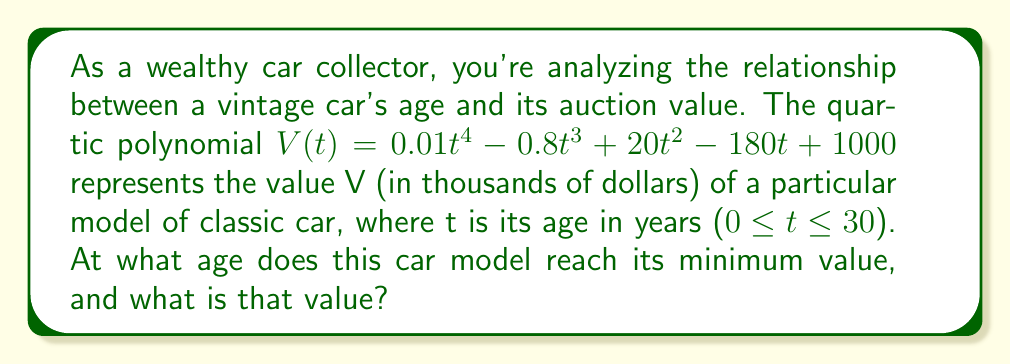Help me with this question. To find the minimum value of the function, we need to follow these steps:

1) First, find the derivative of the function:
   $$V'(t) = 0.04t^3 - 2.4t^2 + 40t - 180$$

2) Set the derivative equal to zero and solve for t:
   $$0.04t^3 - 2.4t^2 + 40t - 180 = 0$$

3) This is a cubic equation. While it can be solved algebraically, it's complex. Using a graphing calculator or computer algebra system, we find the roots are approximately:
   t ≈ 5.37, 15.63, and 39.00

4) Since we're only concerned with 0 ≤ t ≤ 30, we can disregard the last root.

5) To determine which of these critical points gives the minimum value, we can either:
   a) Check the second derivative at these points
   b) Evaluate V(t) at these points and at the endpoints of our interval

6) Let's evaluate V(t) at t = 5.37, 15.63, and also at t = 0 and t = 30:

   V(5.37) ≈ 427.55
   V(15.63) ≈ 425.06
   V(0) = 1000
   V(30) ≈ 2281.00

7) The minimum value occurs at t ≈ 15.63 years.

8) The minimum value is approximately $425,060.
Answer: The car model reaches its minimum value at approximately 15.63 years old, and that minimum value is approximately $425,060. 